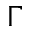<formula> <loc_0><loc_0><loc_500><loc_500>\Gamma</formula> 